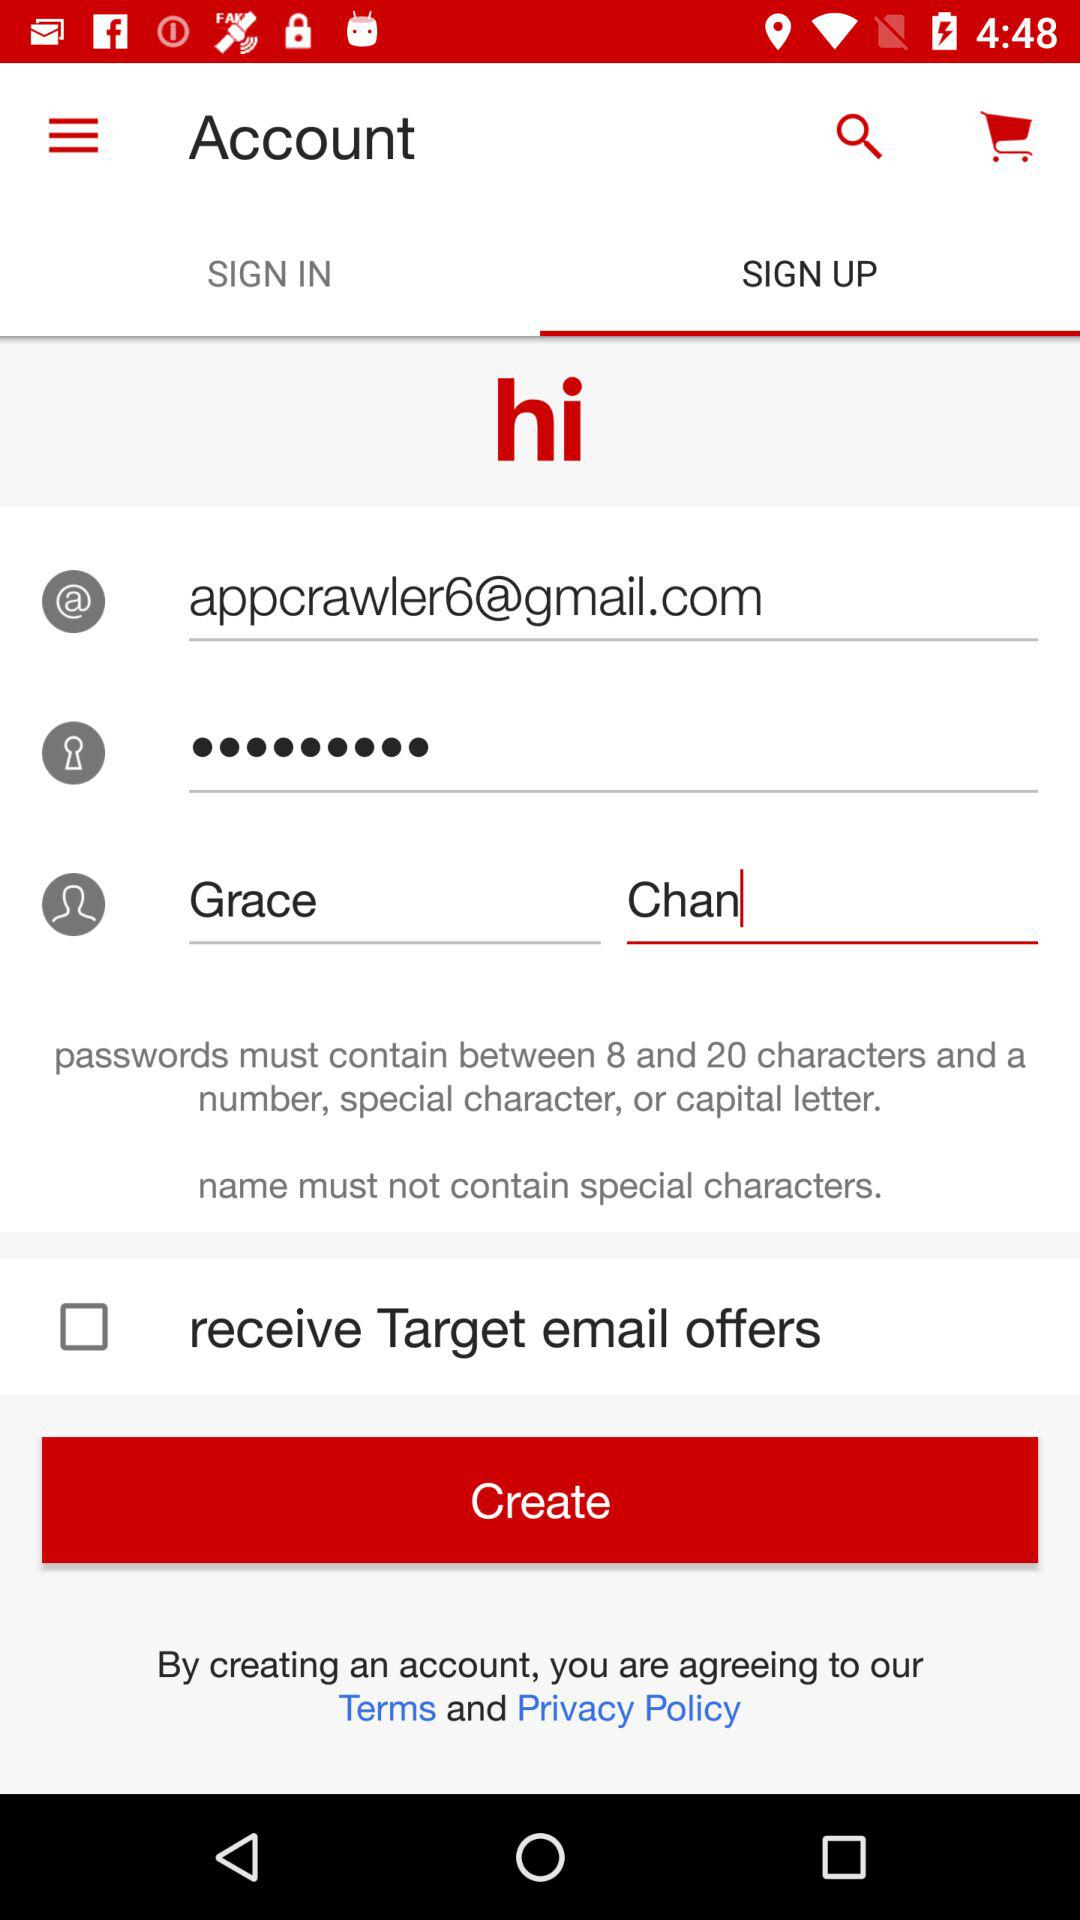What is the name of the user? The name of the user is Grace Chan. 